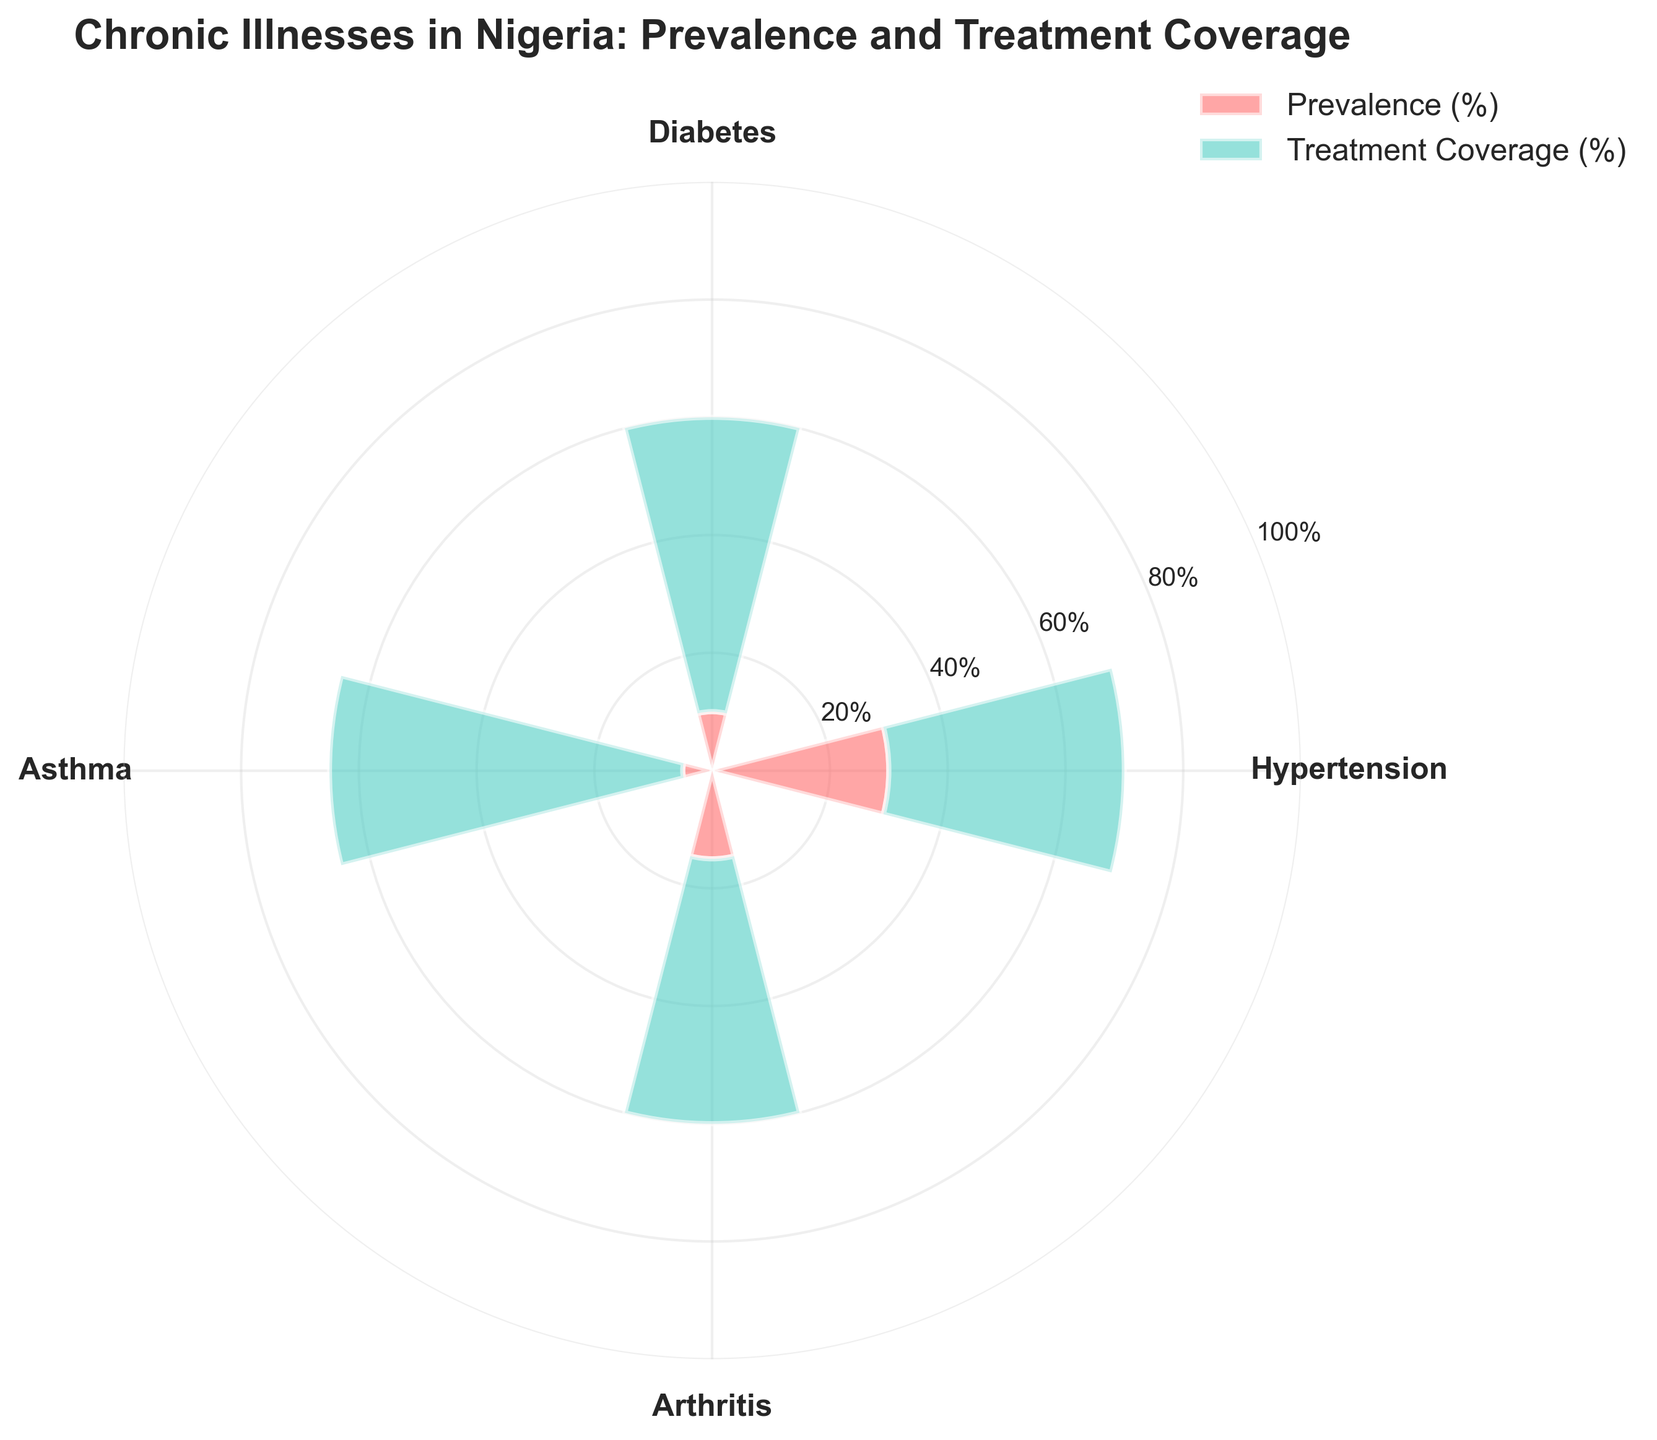What is the prevalence (%) of Hypertension? The prevalence of Hypertension is indicated in the red bar associated with the label "Hypertension". The percentage is shown as 30%.
Answer: 30% What is the treatment coverage (%) of Diabetes? The treatment coverage for Diabetes is shown by the teal-colored bar associated with the label "Diabetes". The percentage is indicated as 50%.
Answer: 50% Which illness has the lowest prevalence (%)? By comparing the height of the red bars, the illness with the lowest red bar is Asthma, with a prevalence of 5%.
Answer: Asthma How many illnesses have a treatment coverage (%) greater than 40%? From the figure, identify the teal bars that are higher than the 40% tick mark. Hypertension (40%), Diabetes (50%), and Asthma (60%) have treatment coverage greater than 40%, making it 3 illnesses.
Answer: 3 Does Hypertension have higher treatment coverage (%) than Arthritis? Compare the height of the teal-colored bars for Hypertension and Arthritis. Hypertension has a treatment coverage of 40%, while Arthritis has a coverage of 45%. Therefore, Hypertension does not have higher treatment coverage than Arthritis.
Answer: No Which illness has the highest treatment coverage (%)? By looking at the height of the teal bars, the illness with the highest teal bar is Asthma, with a treatment coverage of 60%.
Answer: Asthma What is the difference in prevalence (%) between Arthritis and Diabetes? The prevalence of Arthritis is 15% and the prevalence of Diabetes is 10%. The difference is calculated as 15% - 10% = 5%.
Answer: 5% What is the total treatment coverage (%) if we sum up the percentages of all illnesses? Sum the treatment coverage percentages of all illnesses: 40% (Hypertension) + 50% (Diabetes) + 60% (Asthma) + 45% (Arthritis). The total is 40% + 50% + 60% + 45% = 195%.
Answer: 195% Which illness has the highest difference between prevalence (%) and treatment coverage (%)? Calculate the difference between prevalence and treatment coverage for each illness. The differences are: Hypertension: 10%, Diabetes: 40%, Asthma: 55%, Arthritis: 30%. The highest is Asthma with 55%.
Answer: Asthma What is the average prevalence (%) of all the chronic illnesses listed? Sum the prevalence percentages and divide by the number of illnesses. (30% + 10% + 5% + 15%) / 4 = 15%.
Answer: 15% 